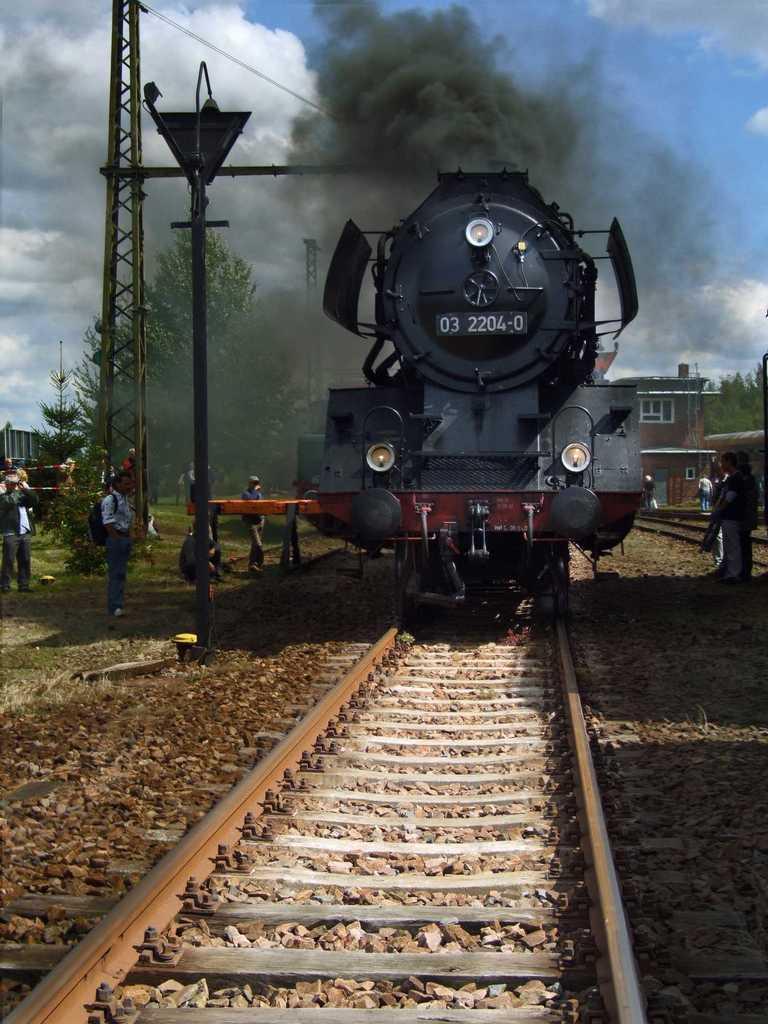Could you give a brief overview of what you see in this image? In the center of the image we can see a train on the track. There are poles. In the background we can see a building and there are trees. At the top there is sky and we can see wires. There are people. 